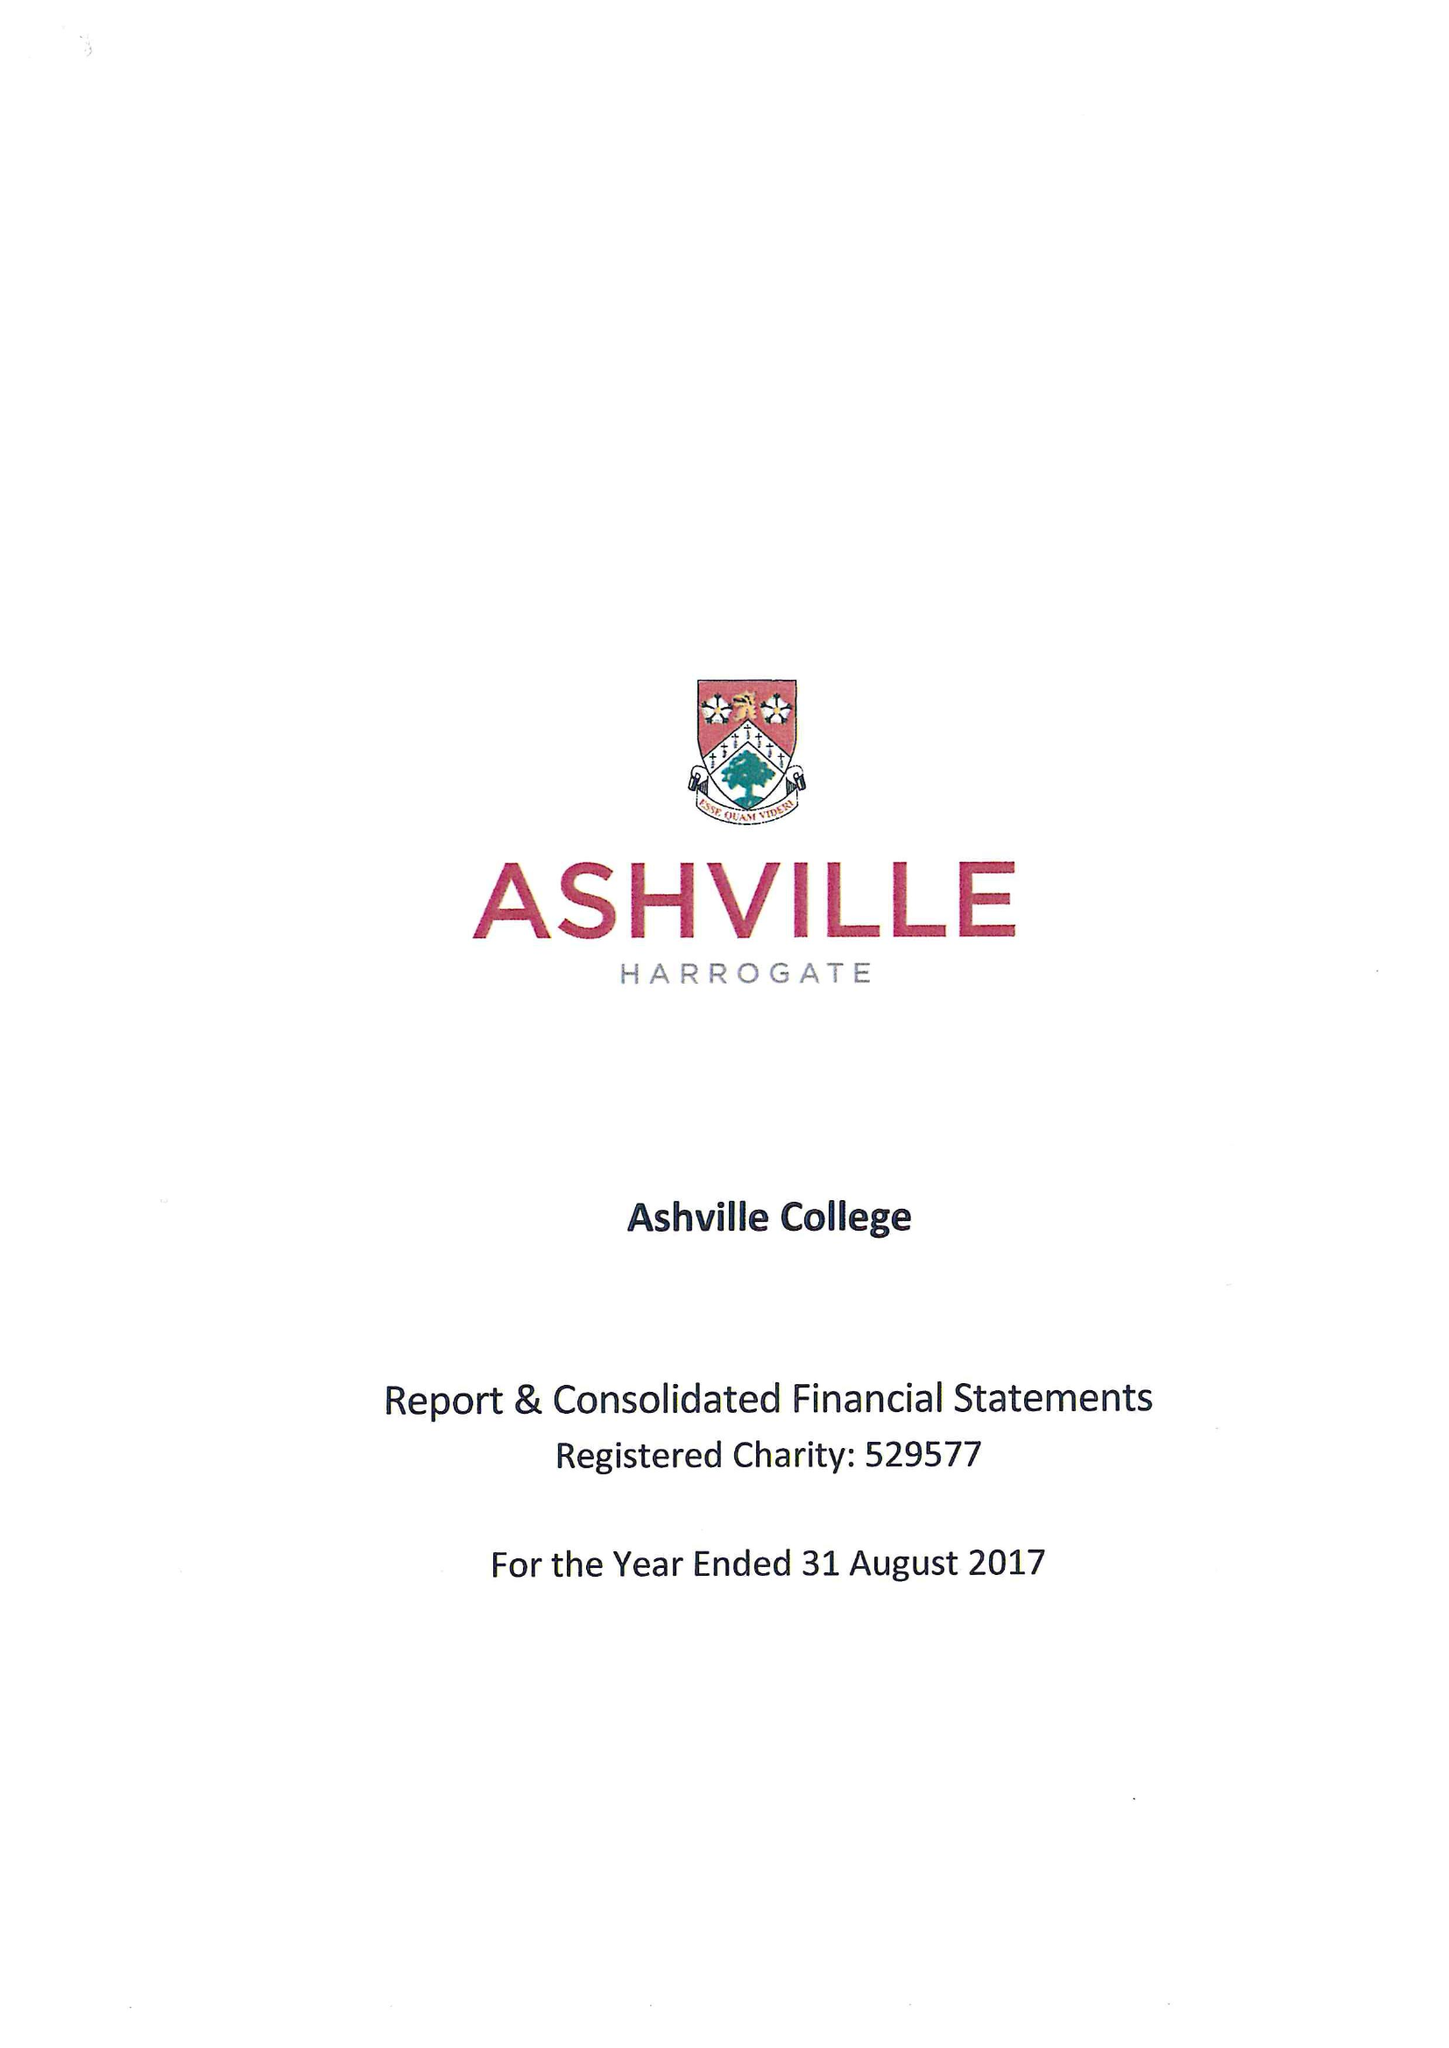What is the value for the income_annually_in_british_pounds?
Answer the question using a single word or phrase. 12290256.00 